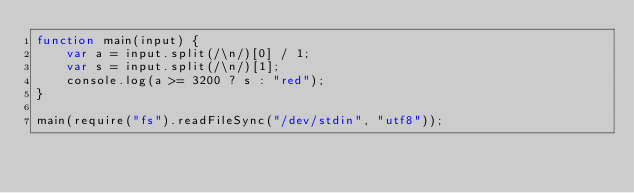Convert code to text. <code><loc_0><loc_0><loc_500><loc_500><_JavaScript_>function main(input) {
    var a = input.split(/\n/)[0] / 1;
    var s = input.split(/\n/)[1];
    console.log(a >= 3200 ? s : "red");
}

main(require("fs").readFileSync("/dev/stdin", "utf8"));
</code> 